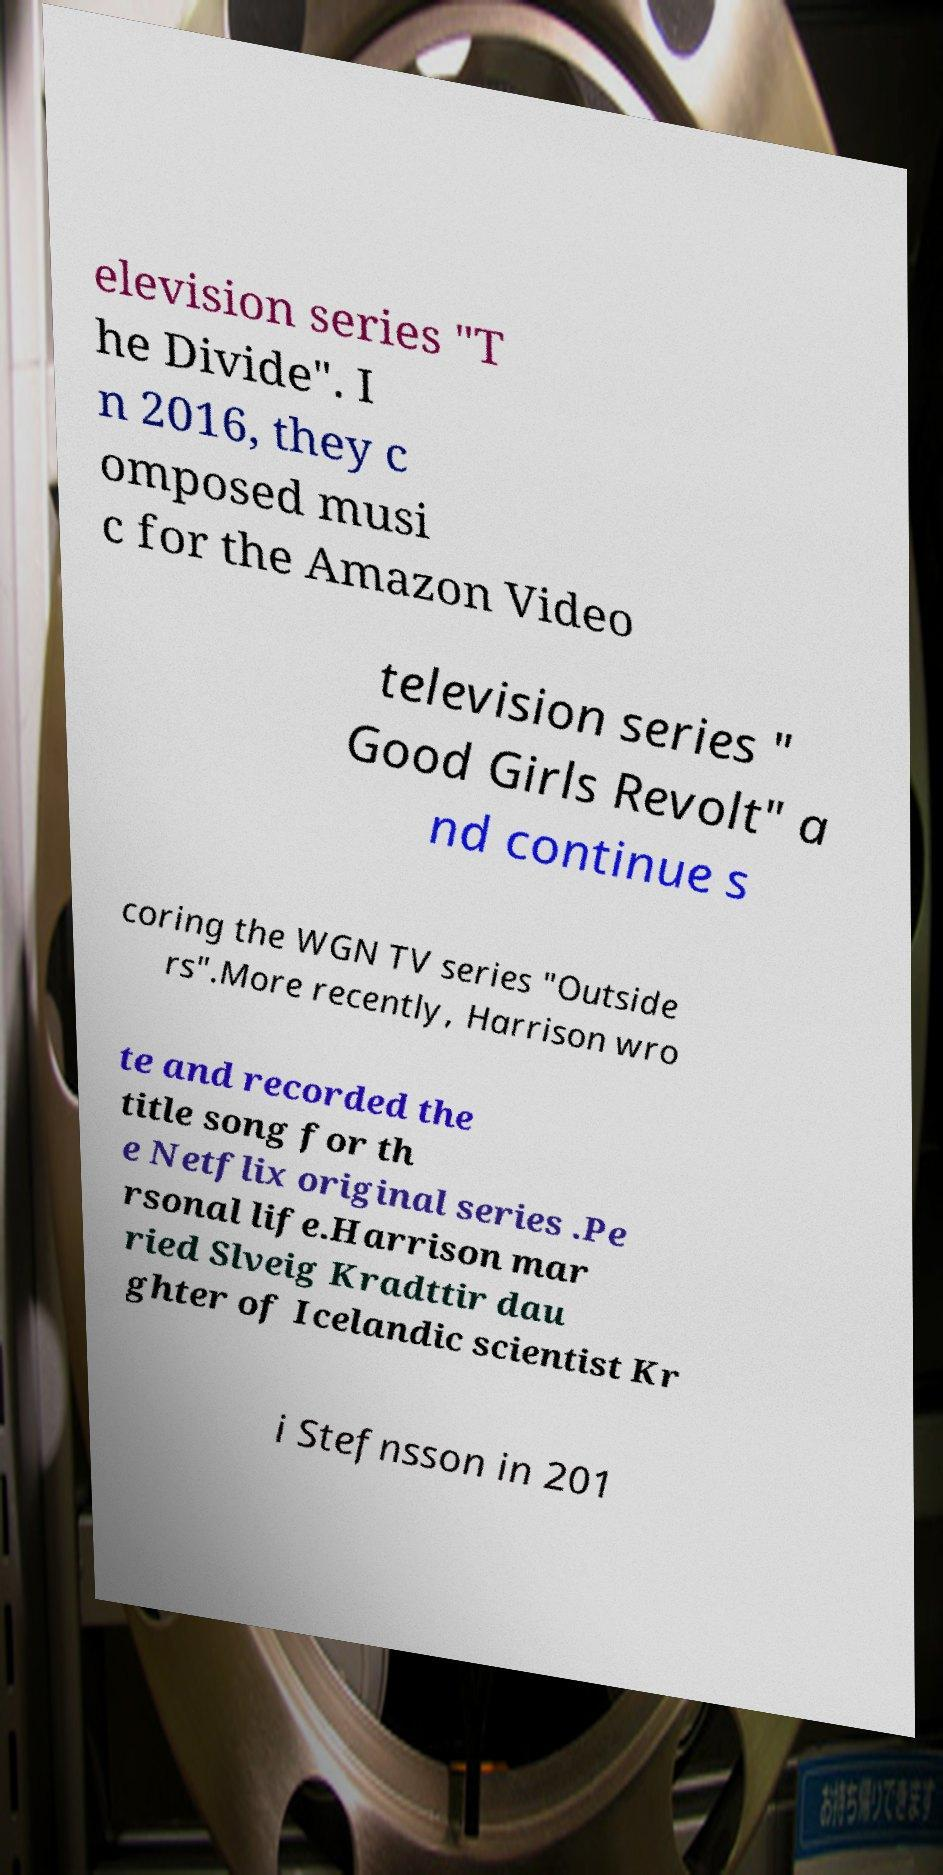Can you read and provide the text displayed in the image?This photo seems to have some interesting text. Can you extract and type it out for me? elevision series "T he Divide". I n 2016, they c omposed musi c for the Amazon Video television series " Good Girls Revolt" a nd continue s coring the WGN TV series "Outside rs".More recently, Harrison wro te and recorded the title song for th e Netflix original series .Pe rsonal life.Harrison mar ried Slveig Kradttir dau ghter of Icelandic scientist Kr i Stefnsson in 201 